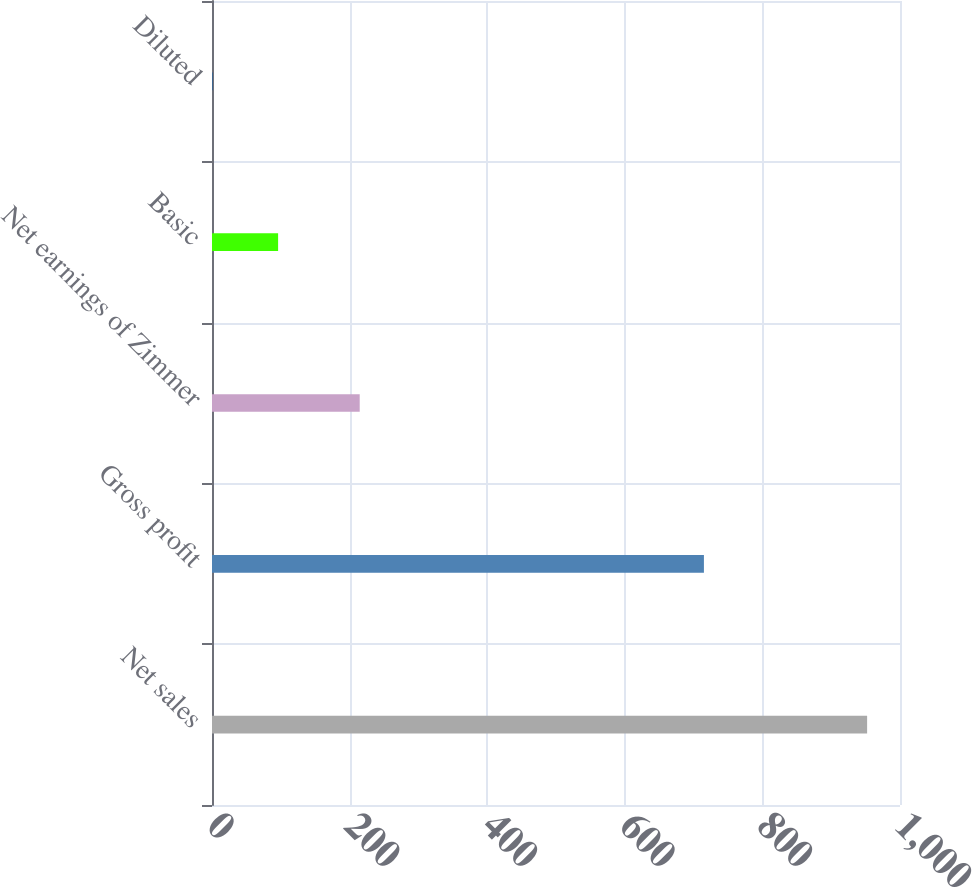<chart> <loc_0><loc_0><loc_500><loc_500><bar_chart><fcel>Net sales<fcel>Gross profit<fcel>Net earnings of Zimmer<fcel>Basic<fcel>Diluted<nl><fcel>952.2<fcel>715<fcel>214.7<fcel>96.08<fcel>0.95<nl></chart> 